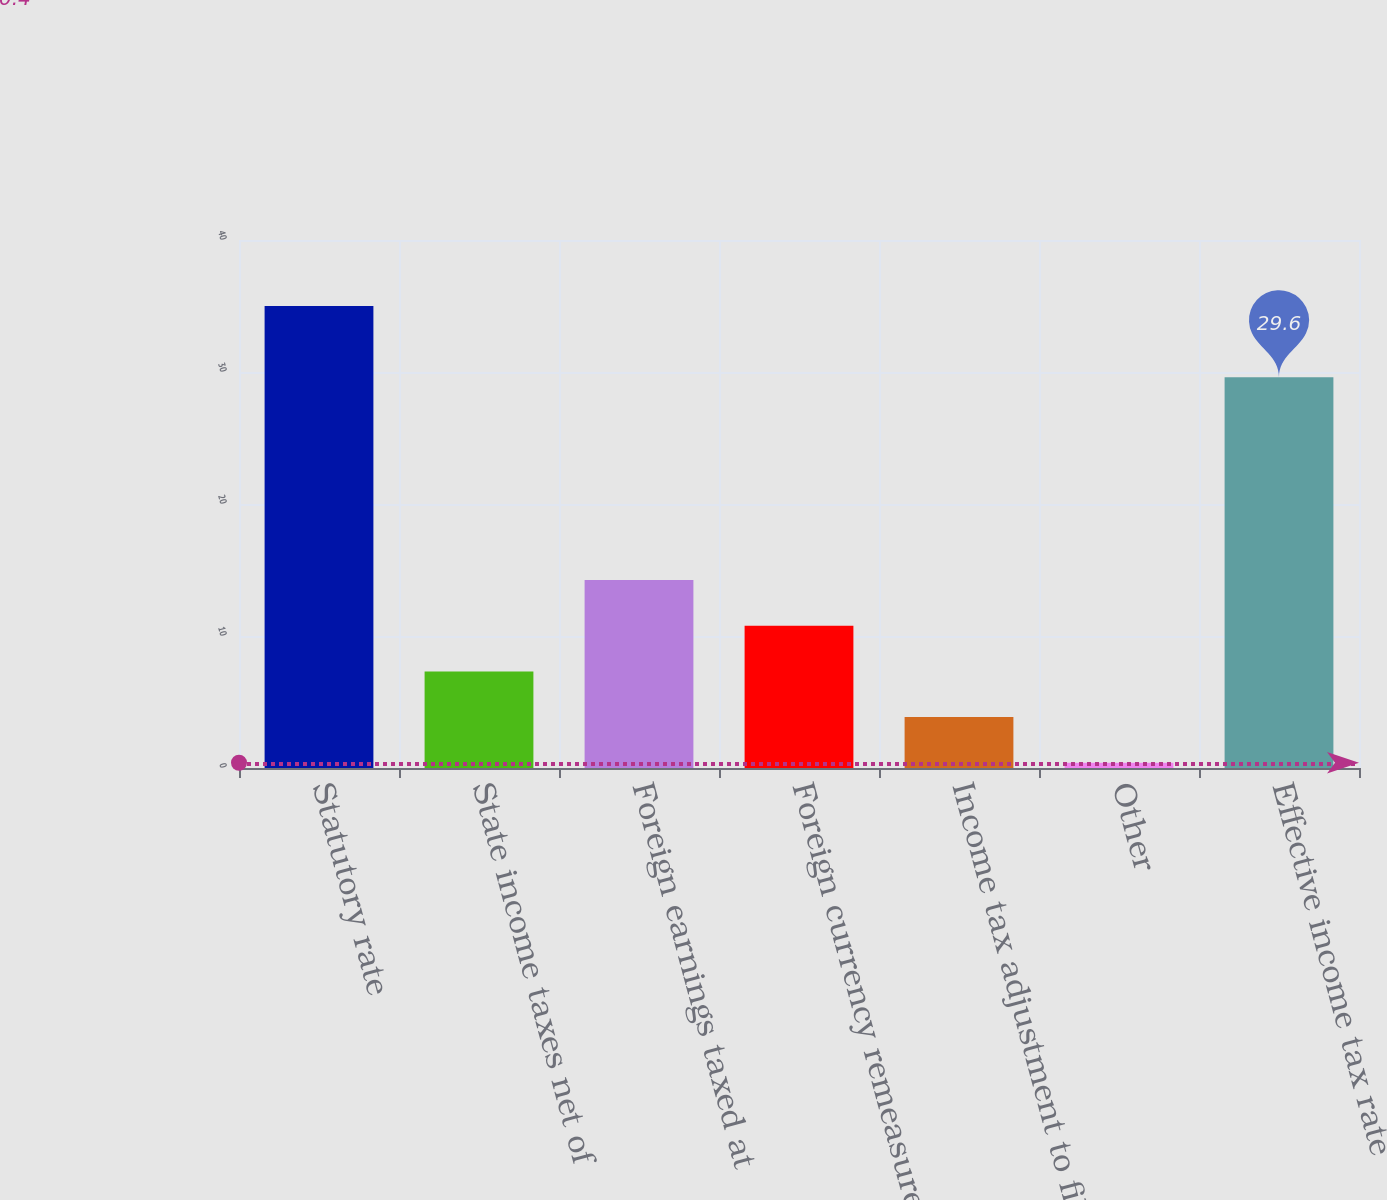Convert chart to OTSL. <chart><loc_0><loc_0><loc_500><loc_500><bar_chart><fcel>Statutory rate<fcel>State income taxes net of<fcel>Foreign earnings taxed at<fcel>Foreign currency remeasurement<fcel>Income tax adjustment to filed<fcel>Other<fcel>Effective income tax rate<nl><fcel>35<fcel>7.32<fcel>14.24<fcel>10.78<fcel>3.86<fcel>0.4<fcel>29.6<nl></chart> 